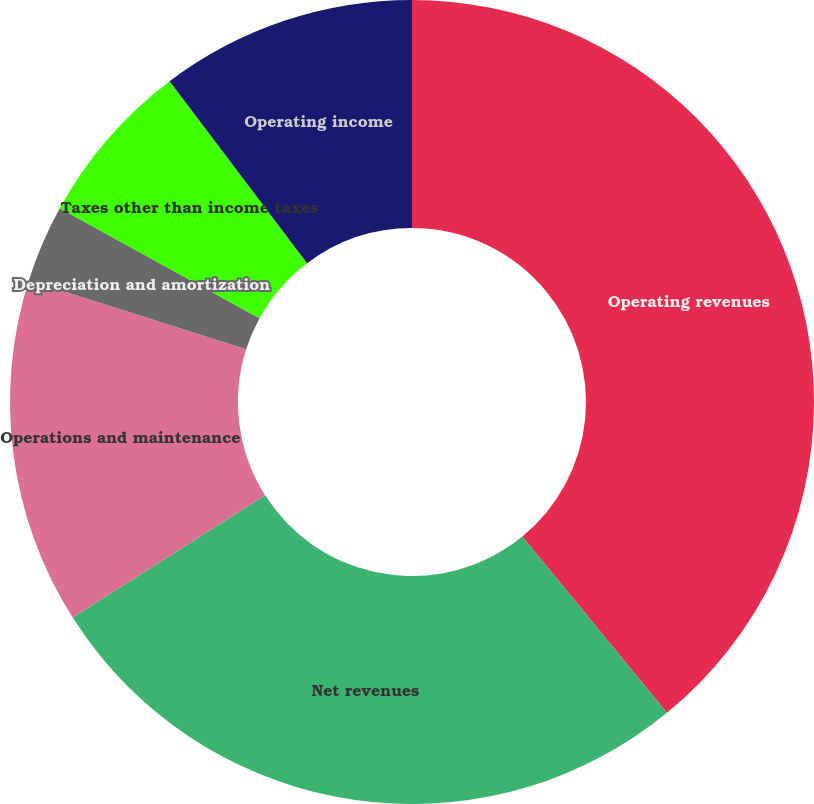<chart> <loc_0><loc_0><loc_500><loc_500><pie_chart><fcel>Operating revenues<fcel>Net revenues<fcel>Operations and maintenance<fcel>Depreciation and amortization<fcel>Taxes other than income taxes<fcel>Operating income<nl><fcel>39.07%<fcel>26.93%<fcel>13.9%<fcel>3.11%<fcel>6.7%<fcel>10.3%<nl></chart> 